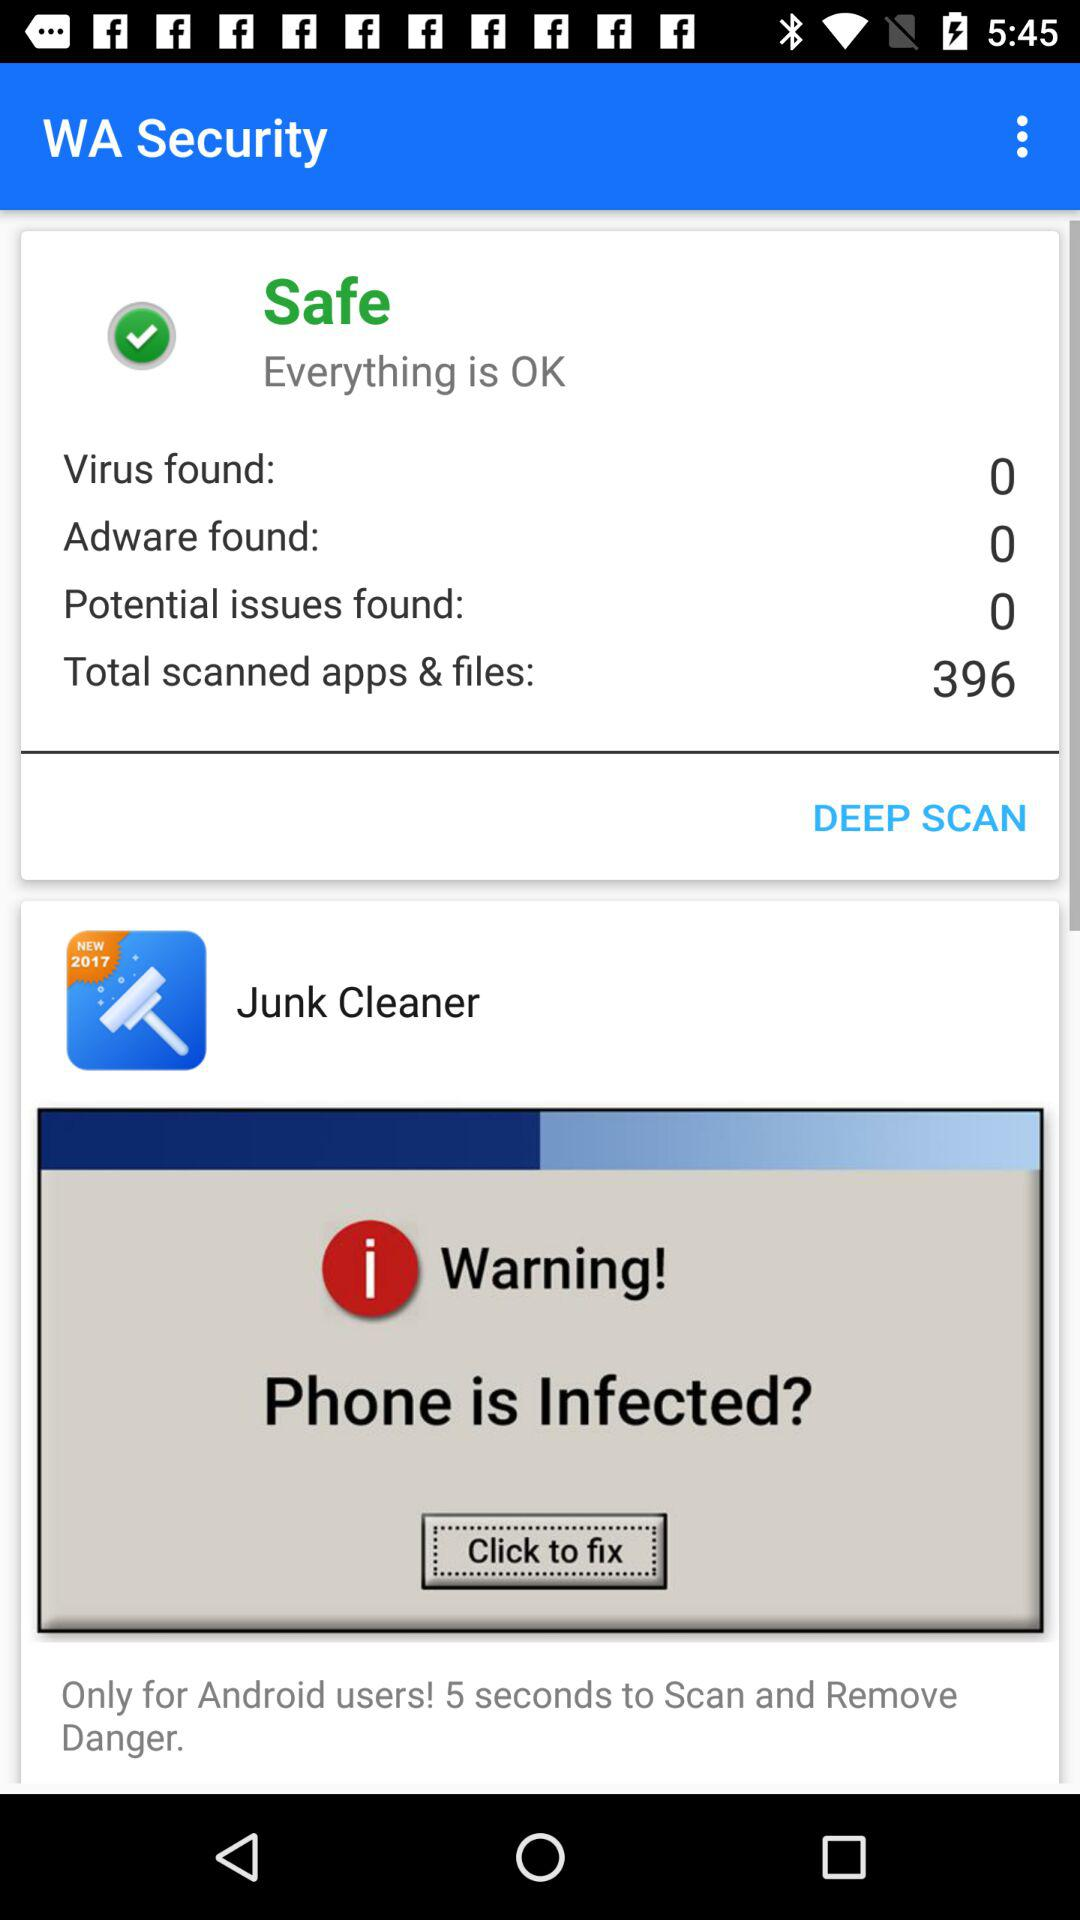How many issues are found on my device?
Answer the question using a single word or phrase. 0 